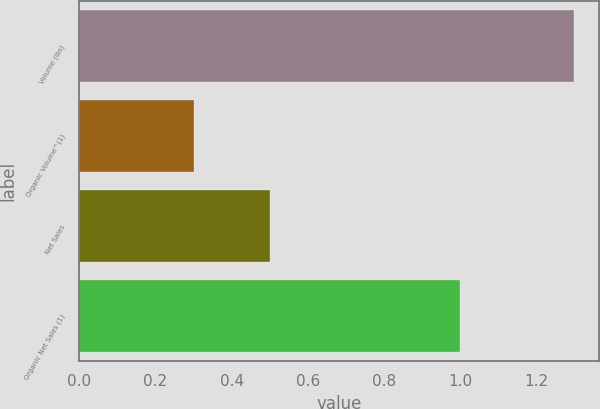Convert chart. <chart><loc_0><loc_0><loc_500><loc_500><bar_chart><fcel>Volume (lbs)<fcel>Organic Volume^(1)<fcel>Net Sales<fcel>Organic Net Sales (1)<nl><fcel>1.3<fcel>0.3<fcel>0.5<fcel>1<nl></chart> 